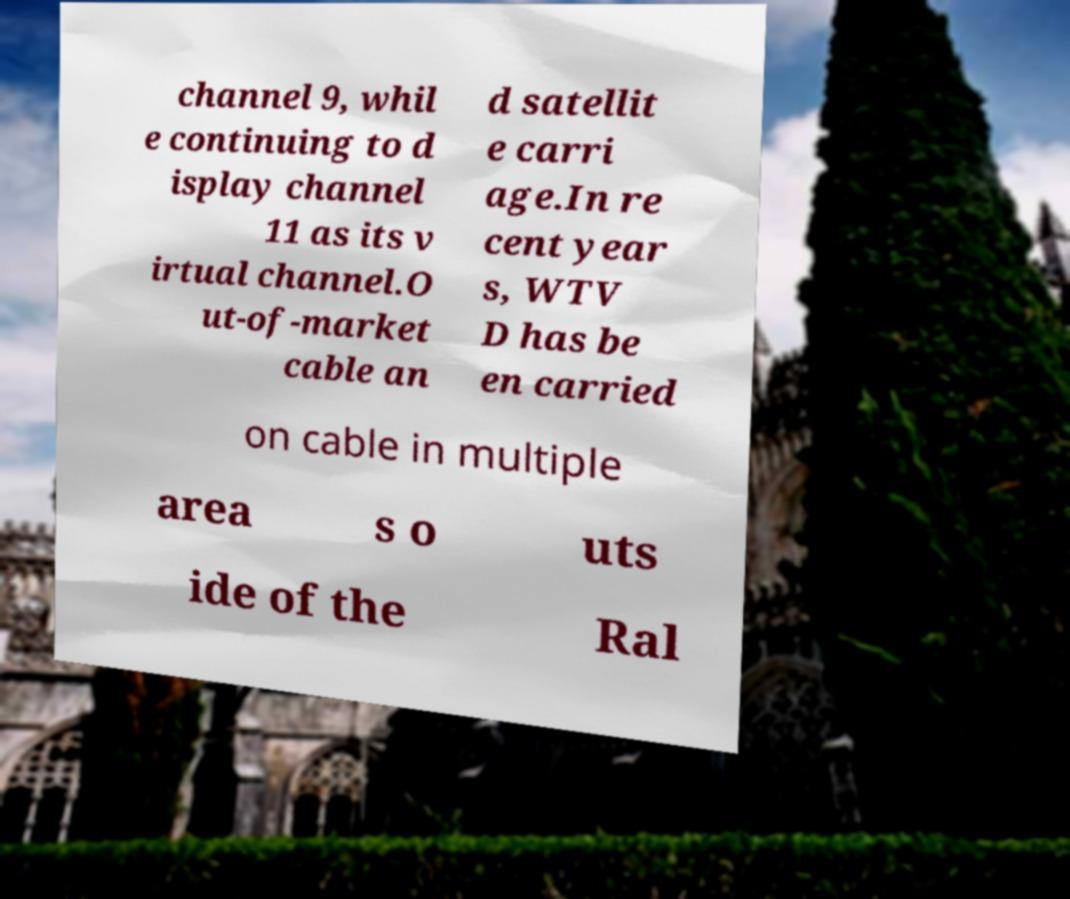Please identify and transcribe the text found in this image. channel 9, whil e continuing to d isplay channel 11 as its v irtual channel.O ut-of-market cable an d satellit e carri age.In re cent year s, WTV D has be en carried on cable in multiple area s o uts ide of the Ral 